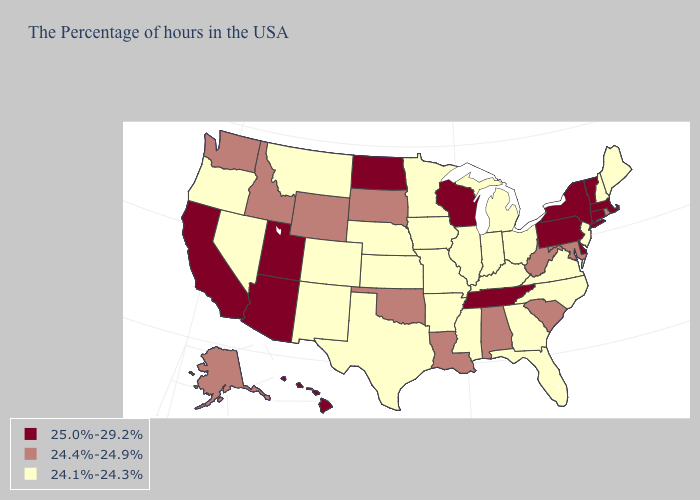Does the first symbol in the legend represent the smallest category?
Keep it brief. No. Name the states that have a value in the range 24.4%-24.9%?
Short answer required. Rhode Island, Maryland, South Carolina, West Virginia, Alabama, Louisiana, Oklahoma, South Dakota, Wyoming, Idaho, Washington, Alaska. What is the lowest value in the USA?
Keep it brief. 24.1%-24.3%. Does the map have missing data?
Answer briefly. No. What is the value of Montana?
Short answer required. 24.1%-24.3%. Among the states that border Louisiana , which have the highest value?
Give a very brief answer. Mississippi, Arkansas, Texas. What is the highest value in states that border Wyoming?
Be succinct. 25.0%-29.2%. What is the lowest value in states that border North Carolina?
Be succinct. 24.1%-24.3%. What is the lowest value in states that border Montana?
Give a very brief answer. 24.4%-24.9%. Name the states that have a value in the range 24.1%-24.3%?
Write a very short answer. Maine, New Hampshire, New Jersey, Virginia, North Carolina, Ohio, Florida, Georgia, Michigan, Kentucky, Indiana, Illinois, Mississippi, Missouri, Arkansas, Minnesota, Iowa, Kansas, Nebraska, Texas, Colorado, New Mexico, Montana, Nevada, Oregon. What is the lowest value in the West?
Answer briefly. 24.1%-24.3%. What is the highest value in states that border California?
Be succinct. 25.0%-29.2%. How many symbols are there in the legend?
Concise answer only. 3. Which states hav the highest value in the West?
Concise answer only. Utah, Arizona, California, Hawaii. 